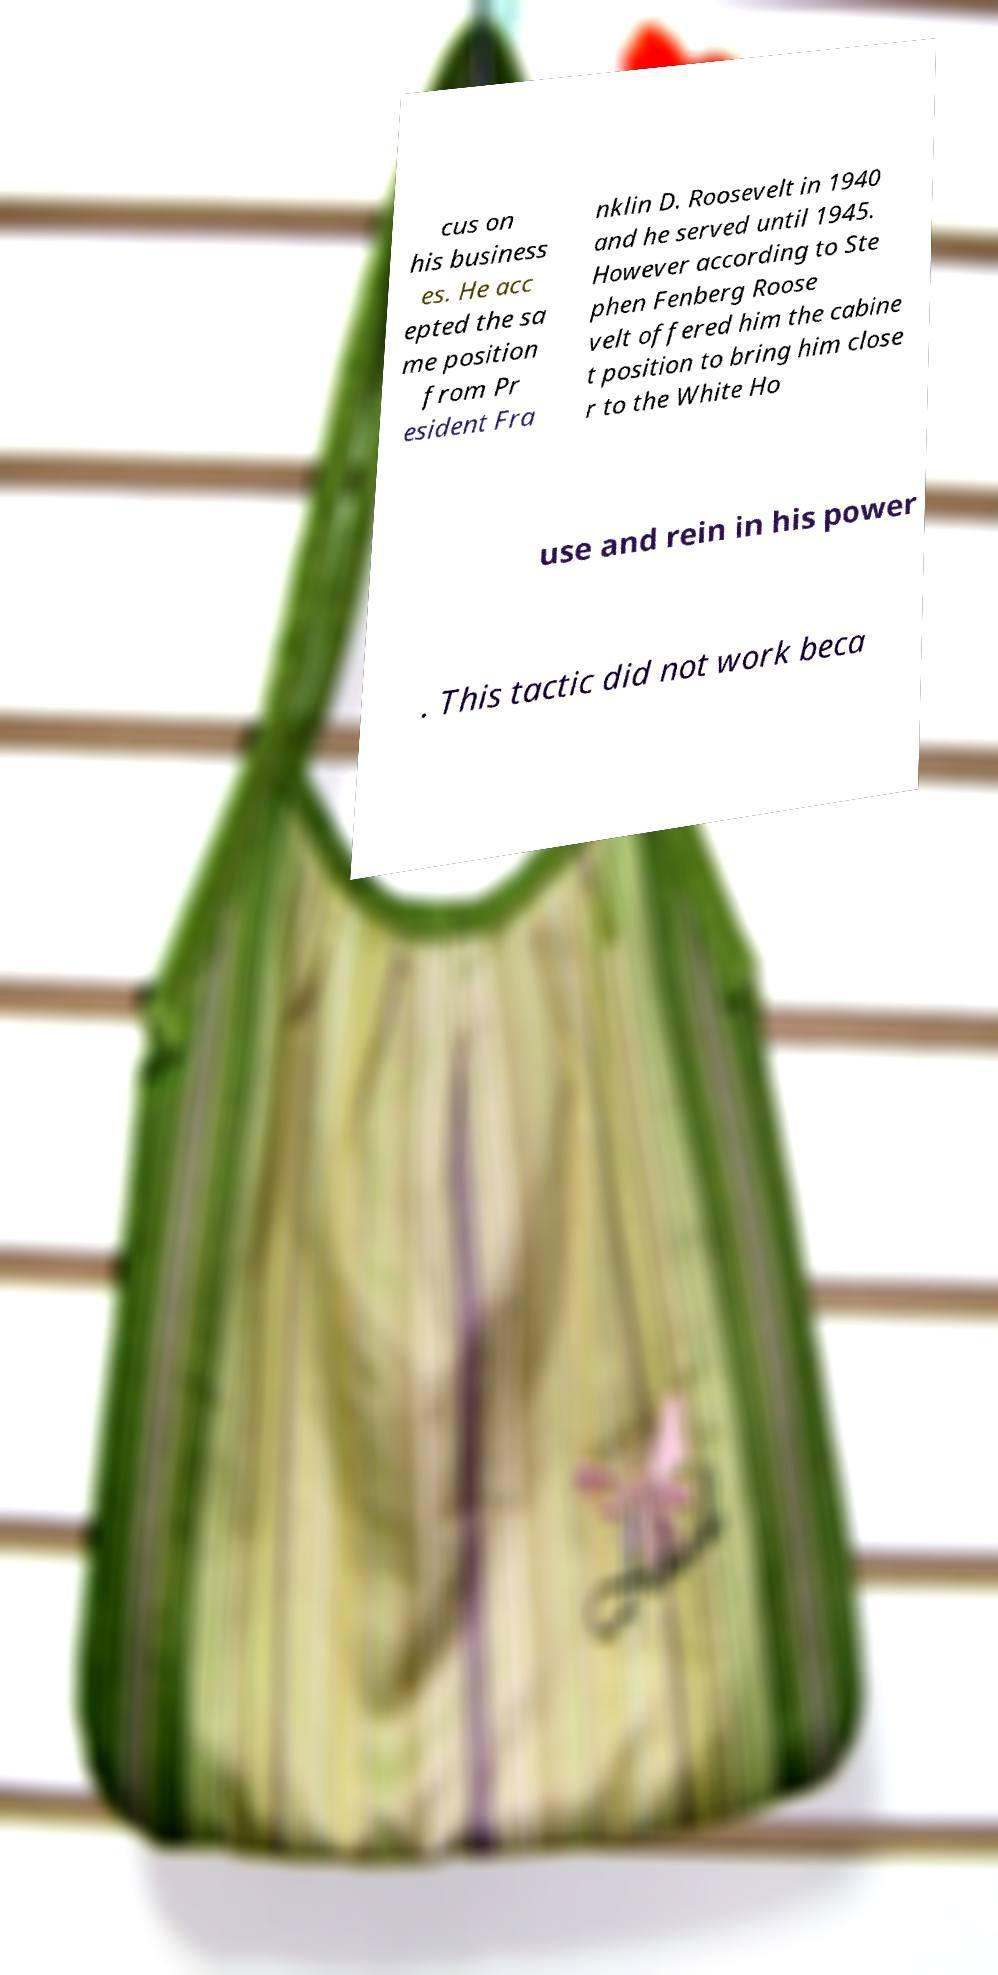Could you extract and type out the text from this image? cus on his business es. He acc epted the sa me position from Pr esident Fra nklin D. Roosevelt in 1940 and he served until 1945. However according to Ste phen Fenberg Roose velt offered him the cabine t position to bring him close r to the White Ho use and rein in his power . This tactic did not work beca 